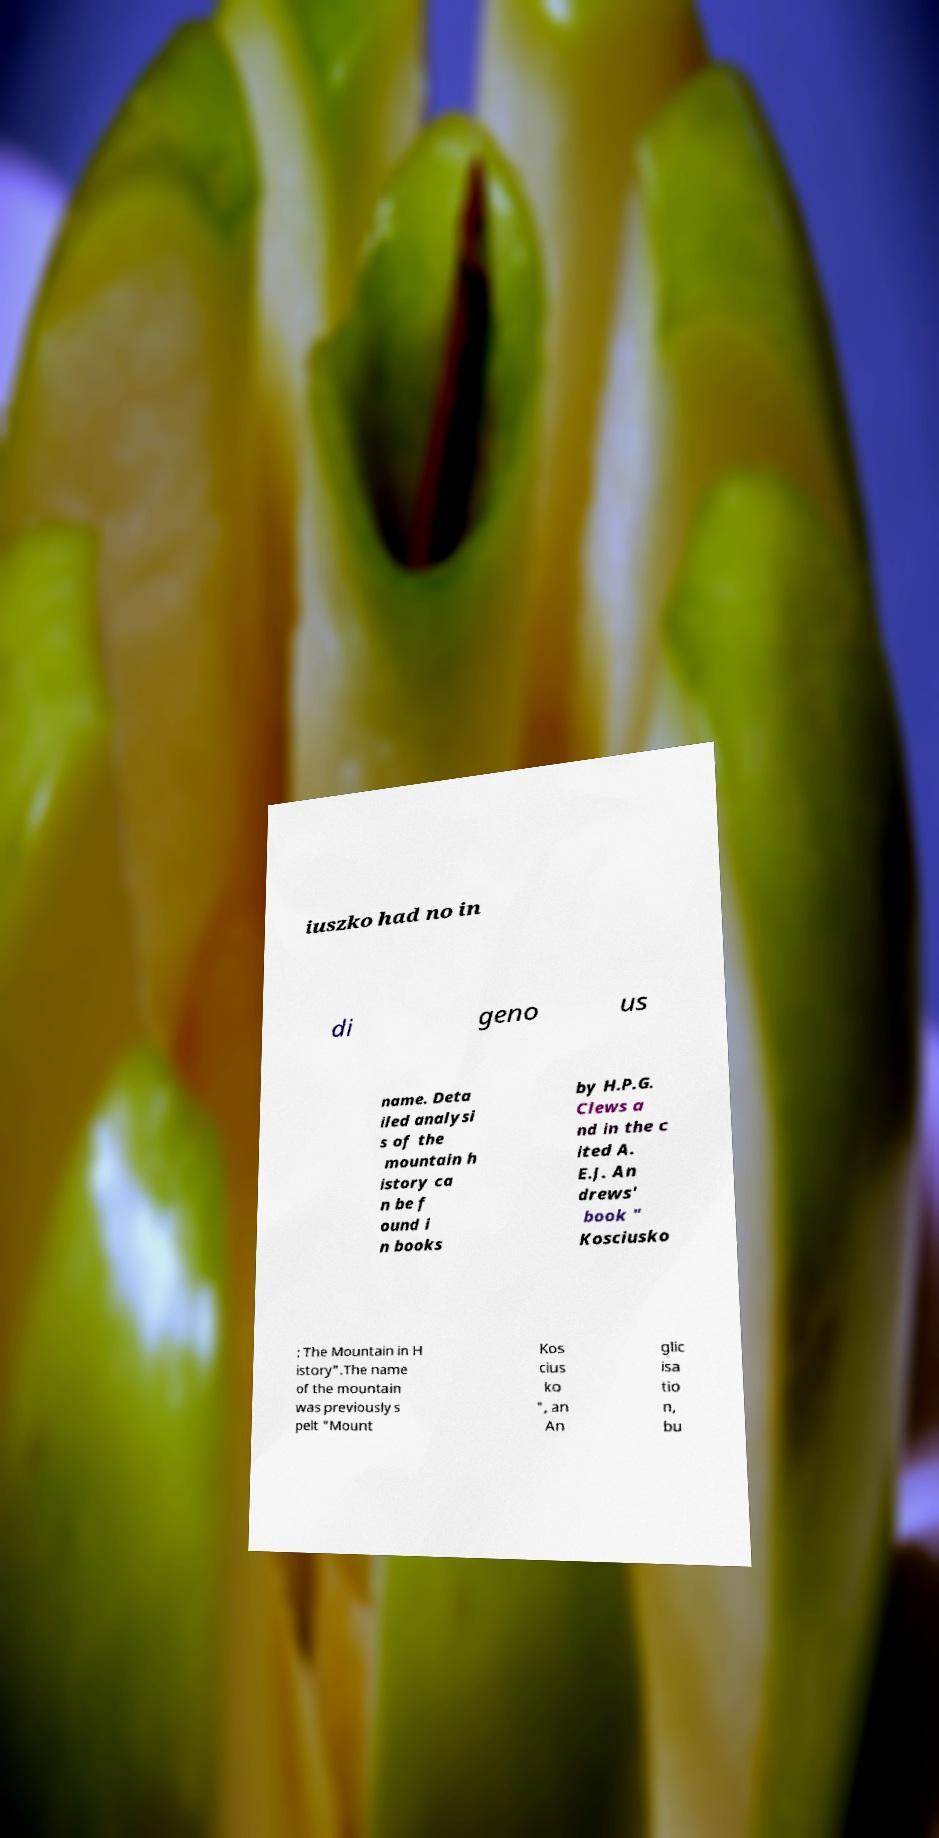I need the written content from this picture converted into text. Can you do that? iuszko had no in di geno us name. Deta iled analysi s of the mountain h istory ca n be f ound i n books by H.P.G. Clews a nd in the c ited A. E.J. An drews' book " Kosciusko : The Mountain in H istory".The name of the mountain was previously s pelt "Mount Kos cius ko ", an An glic isa tio n, bu 